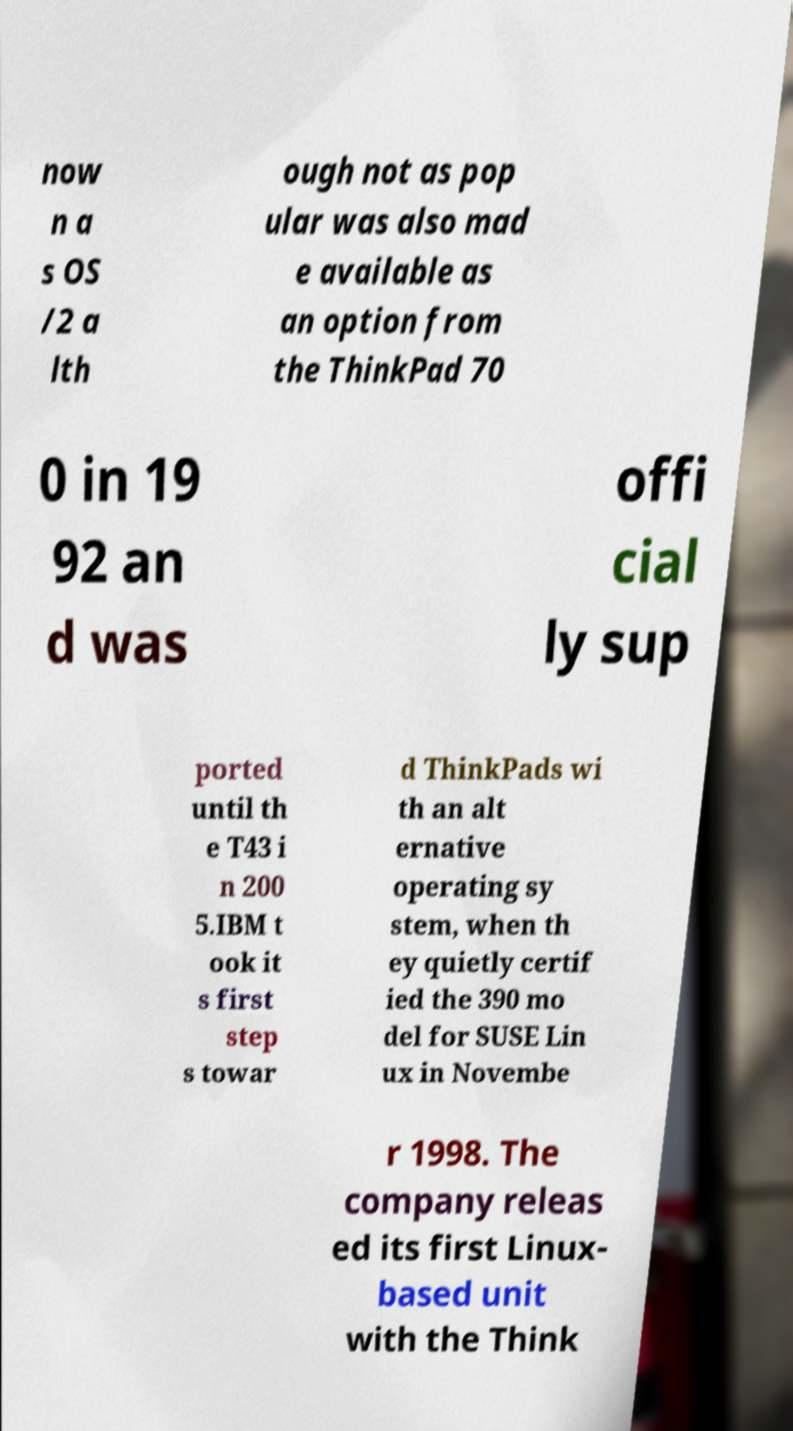Can you accurately transcribe the text from the provided image for me? now n a s OS /2 a lth ough not as pop ular was also mad e available as an option from the ThinkPad 70 0 in 19 92 an d was offi cial ly sup ported until th e T43 i n 200 5.IBM t ook it s first step s towar d ThinkPads wi th an alt ernative operating sy stem, when th ey quietly certif ied the 390 mo del for SUSE Lin ux in Novembe r 1998. The company releas ed its first Linux- based unit with the Think 